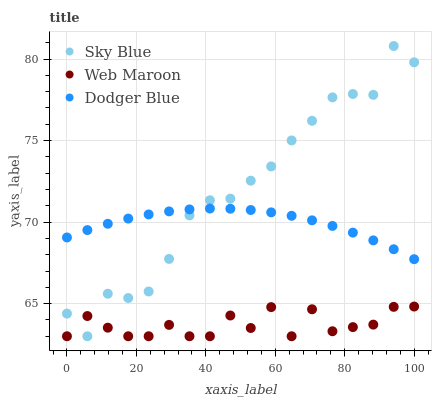Does Web Maroon have the minimum area under the curve?
Answer yes or no. Yes. Does Sky Blue have the maximum area under the curve?
Answer yes or no. Yes. Does Dodger Blue have the minimum area under the curve?
Answer yes or no. No. Does Dodger Blue have the maximum area under the curve?
Answer yes or no. No. Is Dodger Blue the smoothest?
Answer yes or no. Yes. Is Web Maroon the roughest?
Answer yes or no. Yes. Is Web Maroon the smoothest?
Answer yes or no. No. Is Dodger Blue the roughest?
Answer yes or no. No. Does Sky Blue have the lowest value?
Answer yes or no. Yes. Does Dodger Blue have the lowest value?
Answer yes or no. No. Does Sky Blue have the highest value?
Answer yes or no. Yes. Does Dodger Blue have the highest value?
Answer yes or no. No. Is Web Maroon less than Dodger Blue?
Answer yes or no. Yes. Is Dodger Blue greater than Web Maroon?
Answer yes or no. Yes. Does Sky Blue intersect Dodger Blue?
Answer yes or no. Yes. Is Sky Blue less than Dodger Blue?
Answer yes or no. No. Is Sky Blue greater than Dodger Blue?
Answer yes or no. No. Does Web Maroon intersect Dodger Blue?
Answer yes or no. No. 